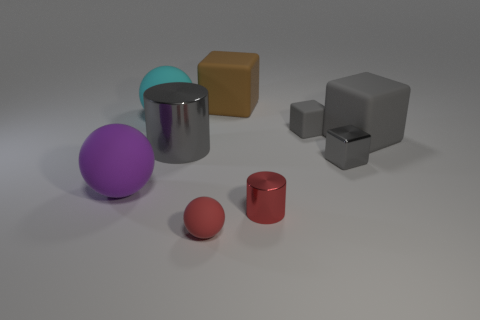How many gray cubes must be subtracted to get 1 gray cubes? 2 Subtract all metallic blocks. How many blocks are left? 3 Subtract all gray cylinders. How many cylinders are left? 1 Subtract all blocks. How many objects are left? 5 Subtract all purple spheres. How many green cubes are left? 0 Subtract all big gray rubber things. Subtract all shiny cylinders. How many objects are left? 6 Add 3 large gray cylinders. How many large gray cylinders are left? 4 Add 9 tiny purple cubes. How many tiny purple cubes exist? 9 Subtract 1 gray cylinders. How many objects are left? 8 Subtract 2 balls. How many balls are left? 1 